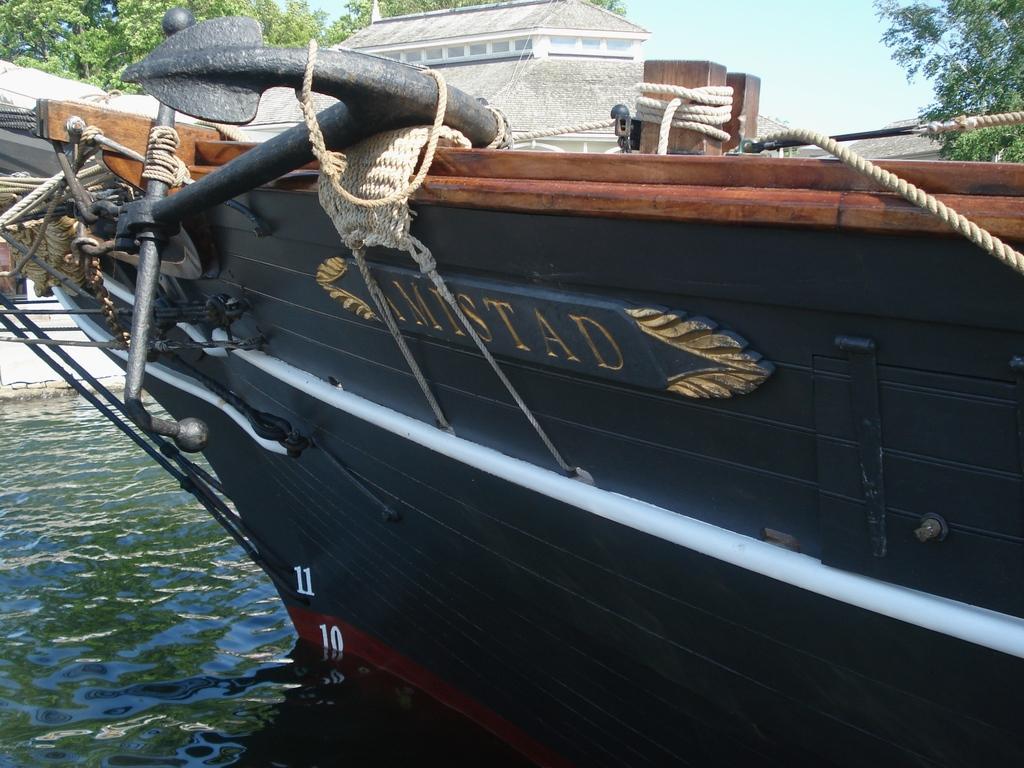In one or two sentences, can you explain what this image depicts? In the picture we can see a boat which is black in color and some ropes to it and anchor tied to it and it is in the water, in the background we can see some trees, house building and sky. 